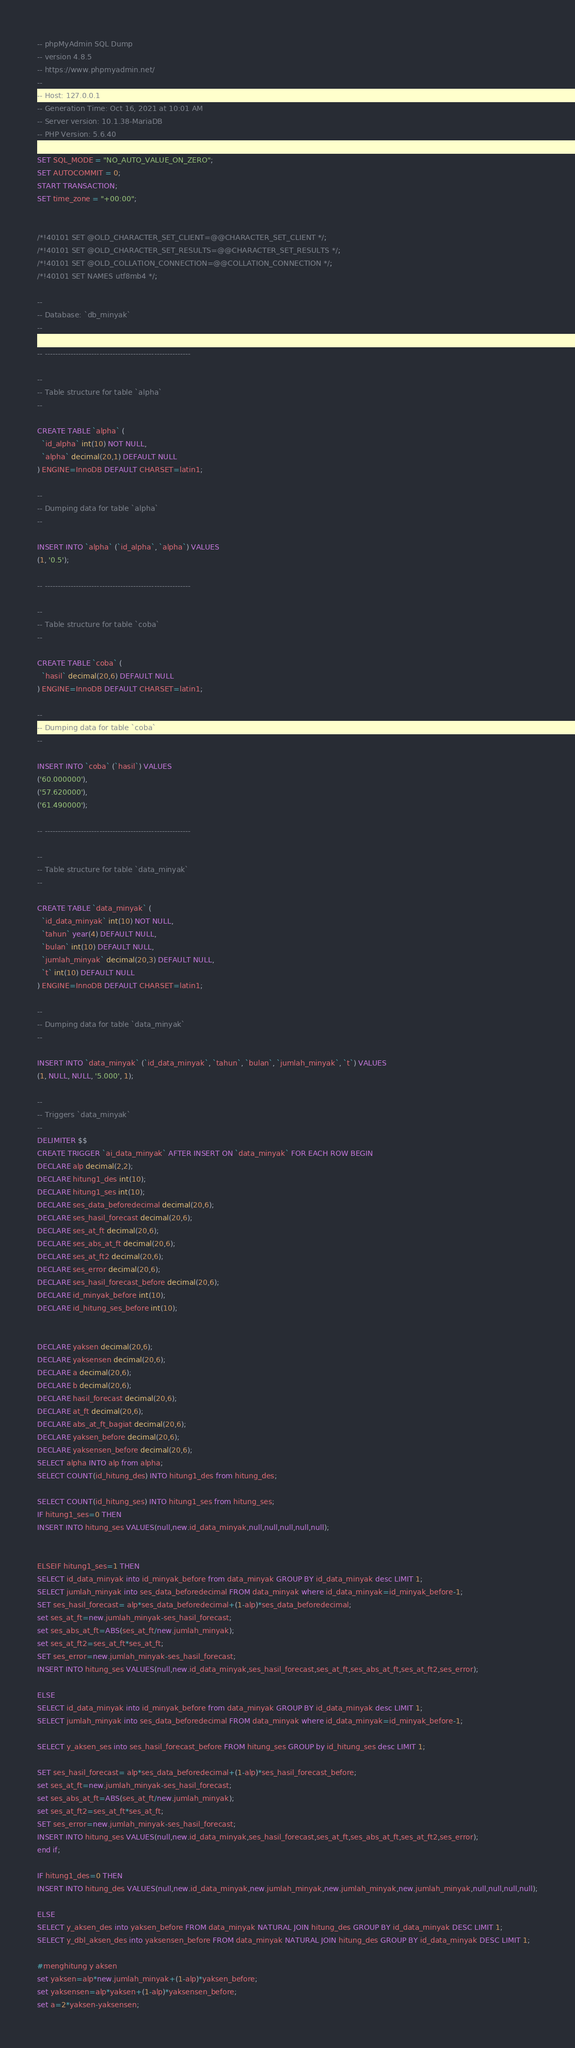Convert code to text. <code><loc_0><loc_0><loc_500><loc_500><_SQL_>-- phpMyAdmin SQL Dump
-- version 4.8.5
-- https://www.phpmyadmin.net/
--
-- Host: 127.0.0.1
-- Generation Time: Oct 16, 2021 at 10:01 AM
-- Server version: 10.1.38-MariaDB
-- PHP Version: 5.6.40

SET SQL_MODE = "NO_AUTO_VALUE_ON_ZERO";
SET AUTOCOMMIT = 0;
START TRANSACTION;
SET time_zone = "+00:00";


/*!40101 SET @OLD_CHARACTER_SET_CLIENT=@@CHARACTER_SET_CLIENT */;
/*!40101 SET @OLD_CHARACTER_SET_RESULTS=@@CHARACTER_SET_RESULTS */;
/*!40101 SET @OLD_COLLATION_CONNECTION=@@COLLATION_CONNECTION */;
/*!40101 SET NAMES utf8mb4 */;

--
-- Database: `db_minyak`
--

-- --------------------------------------------------------

--
-- Table structure for table `alpha`
--

CREATE TABLE `alpha` (
  `id_alpha` int(10) NOT NULL,
  `alpha` decimal(20,1) DEFAULT NULL
) ENGINE=InnoDB DEFAULT CHARSET=latin1;

--
-- Dumping data for table `alpha`
--

INSERT INTO `alpha` (`id_alpha`, `alpha`) VALUES
(1, '0.5');

-- --------------------------------------------------------

--
-- Table structure for table `coba`
--

CREATE TABLE `coba` (
  `hasil` decimal(20,6) DEFAULT NULL
) ENGINE=InnoDB DEFAULT CHARSET=latin1;

--
-- Dumping data for table `coba`
--

INSERT INTO `coba` (`hasil`) VALUES
('60.000000'),
('57.620000'),
('61.490000');

-- --------------------------------------------------------

--
-- Table structure for table `data_minyak`
--

CREATE TABLE `data_minyak` (
  `id_data_minyak` int(10) NOT NULL,
  `tahun` year(4) DEFAULT NULL,
  `bulan` int(10) DEFAULT NULL,
  `jumlah_minyak` decimal(20,3) DEFAULT NULL,
  `t` int(10) DEFAULT NULL
) ENGINE=InnoDB DEFAULT CHARSET=latin1;

--
-- Dumping data for table `data_minyak`
--

INSERT INTO `data_minyak` (`id_data_minyak`, `tahun`, `bulan`, `jumlah_minyak`, `t`) VALUES
(1, NULL, NULL, '5.000', 1);

--
-- Triggers `data_minyak`
--
DELIMITER $$
CREATE TRIGGER `ai_data_minyak` AFTER INSERT ON `data_minyak` FOR EACH ROW BEGIN
DECLARE alp decimal(2,2);
DECLARE hitung1_des int(10);
DECLARE hitung1_ses int(10);
DECLARE ses_data_beforedecimal decimal(20,6);
DECLARE ses_hasil_forecast decimal(20,6);
DECLARE ses_at_ft decimal(20,6);
DECLARE ses_abs_at_ft decimal(20,6);
DECLARE ses_at_ft2 decimal(20,6);
DECLARE ses_error decimal(20,6);
DECLARE ses_hasil_forecast_before decimal(20,6);
DECLARE id_minyak_before int(10);
DECLARE id_hitung_ses_before int(10);


DECLARE yaksen decimal(20,6);
DECLARE yaksensen decimal(20,6);
DECLARE a decimal(20,6);
DECLARE b decimal(20,6);
DECLARE hasil_forecast decimal(20,6);
DECLARE at_ft decimal(20,6);
DECLARE abs_at_ft_bagiat decimal(20,6);
DECLARE yaksen_before decimal(20,6);
DECLARE yaksensen_before decimal(20,6);
SELECT alpha INTO alp from alpha;
SELECT COUNT(id_hitung_des) INTO hitung1_des from hitung_des;

SELECT COUNT(id_hitung_ses) INTO hitung1_ses from hitung_ses;
IF hitung1_ses=0 THEN
INSERT INTO hitung_ses VALUES(null,new.id_data_minyak,null,null,null,null,null);


ELSEIF hitung1_ses=1 THEN
SELECT id_data_minyak into id_minyak_before from data_minyak GROUP BY id_data_minyak desc LIMIT 1;
SELECT jumlah_minyak into ses_data_beforedecimal FROM data_minyak where id_data_minyak=id_minyak_before-1;
SET ses_hasil_forecast= alp*ses_data_beforedecimal+(1-alp)*ses_data_beforedecimal;
set ses_at_ft=new.jumlah_minyak-ses_hasil_forecast;
set ses_abs_at_ft=ABS(ses_at_ft/new.jumlah_minyak);
set ses_at_ft2=ses_at_ft*ses_at_ft;
SET ses_error=new.jumlah_minyak-ses_hasil_forecast;
INSERT INTO hitung_ses VALUES(null,new.id_data_minyak,ses_hasil_forecast,ses_at_ft,ses_abs_at_ft,ses_at_ft2,ses_error);

ELSE
SELECT id_data_minyak into id_minyak_before from data_minyak GROUP BY id_data_minyak desc LIMIT 1;
SELECT jumlah_minyak into ses_data_beforedecimal FROM data_minyak where id_data_minyak=id_minyak_before-1;

SELECT y_aksen_ses into ses_hasil_forecast_before FROM hitung_ses GROUP by id_hitung_ses desc LIMIT 1;

SET ses_hasil_forecast= alp*ses_data_beforedecimal+(1-alp)*ses_hasil_forecast_before;
set ses_at_ft=new.jumlah_minyak-ses_hasil_forecast;
set ses_abs_at_ft=ABS(ses_at_ft/new.jumlah_minyak);
set ses_at_ft2=ses_at_ft*ses_at_ft;
SET ses_error=new.jumlah_minyak-ses_hasil_forecast;
INSERT INTO hitung_ses VALUES(null,new.id_data_minyak,ses_hasil_forecast,ses_at_ft,ses_abs_at_ft,ses_at_ft2,ses_error);
end if;

IF hitung1_des=0 THEN
INSERT INTO hitung_des VALUES(null,new.id_data_minyak,new.jumlah_minyak,new.jumlah_minyak,new.jumlah_minyak,null,null,null,null);

ELSE 
SELECT y_aksen_des into yaksen_before FROM data_minyak NATURAL JOIN hitung_des GROUP BY id_data_minyak DESC LIMIT 1;
SELECT y_dbl_aksen_des into yaksensen_before FROM data_minyak NATURAL JOIN hitung_des GROUP BY id_data_minyak DESC LIMIT 1;

#menghitung y aksen
set yaksen=alp*new.jumlah_minyak+(1-alp)*yaksen_before;
set yaksensen=alp*yaksen+(1-alp)*yaksensen_before;
set a=2*yaksen-yaksensen;</code> 